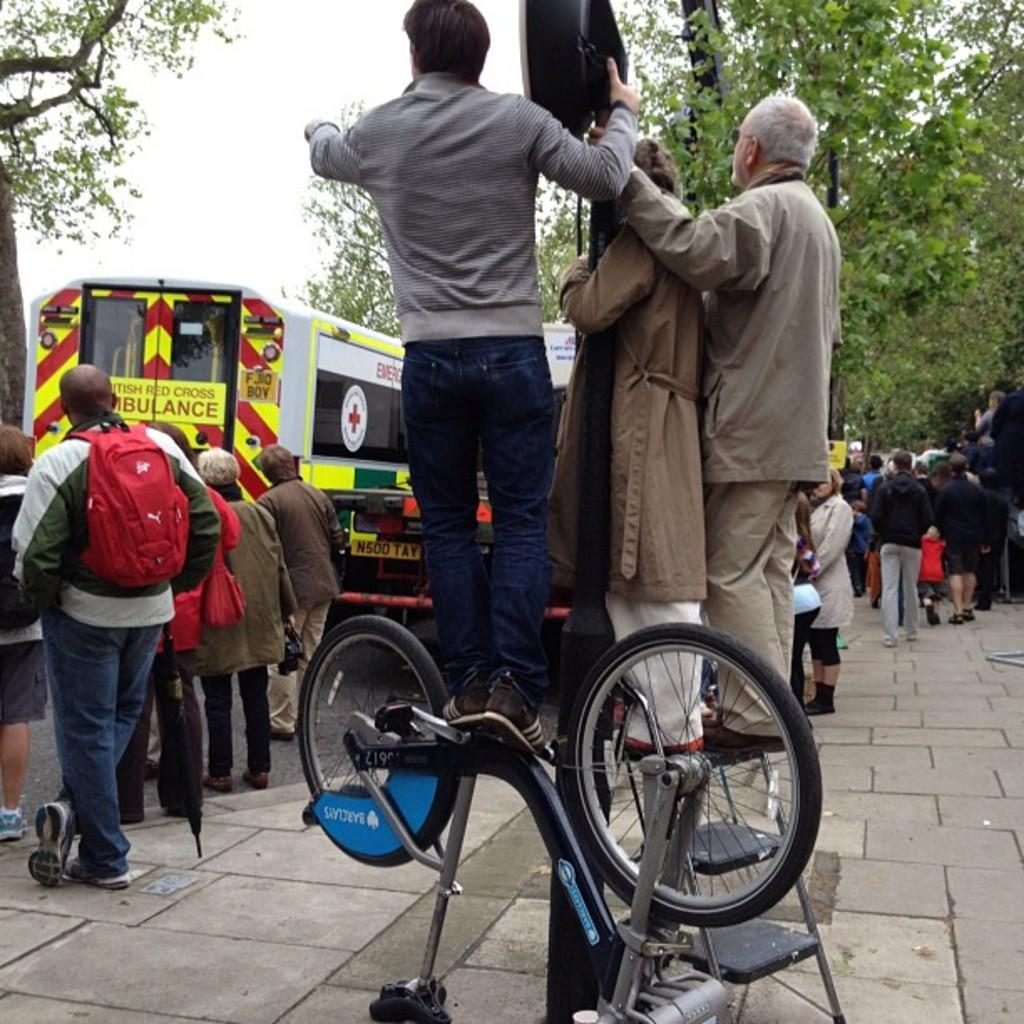How many people are in the image? There is a group of people in the image, but the exact number is not specified. What are the people in the image doing? Some people are standing, while others are walking. What object is present in front of the people? There is a ladder in front of the people. Are people interacting with the ladder? Yes, people are standing on the ladder. What is visible at the top of the image? The sky is visible at the top of the image. What type of vegetation can be seen in the image? There is a tree at the back of the image. What type of humor can be seen in the air between the people in the image? There is no indication of humor or any air-related interactions between the people in the image. Is there a competition taking place between the people in the image? The image does not show any evidence of a competition or any competitive activities among the people. 